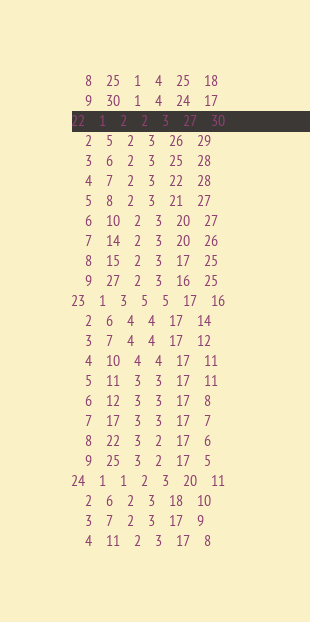<code> <loc_0><loc_0><loc_500><loc_500><_ObjectiveC_>	8	25	1	4	25	18	
	9	30	1	4	24	17	
22	1	2	2	3	27	30	
	2	5	2	3	26	29	
	3	6	2	3	25	28	
	4	7	2	3	22	28	
	5	8	2	3	21	27	
	6	10	2	3	20	27	
	7	14	2	3	20	26	
	8	15	2	3	17	25	
	9	27	2	3	16	25	
23	1	3	5	5	17	16	
	2	6	4	4	17	14	
	3	7	4	4	17	12	
	4	10	4	4	17	11	
	5	11	3	3	17	11	
	6	12	3	3	17	8	
	7	17	3	3	17	7	
	8	22	3	2	17	6	
	9	25	3	2	17	5	
24	1	1	2	3	20	11	
	2	6	2	3	18	10	
	3	7	2	3	17	9	
	4	11	2	3	17	8	</code> 